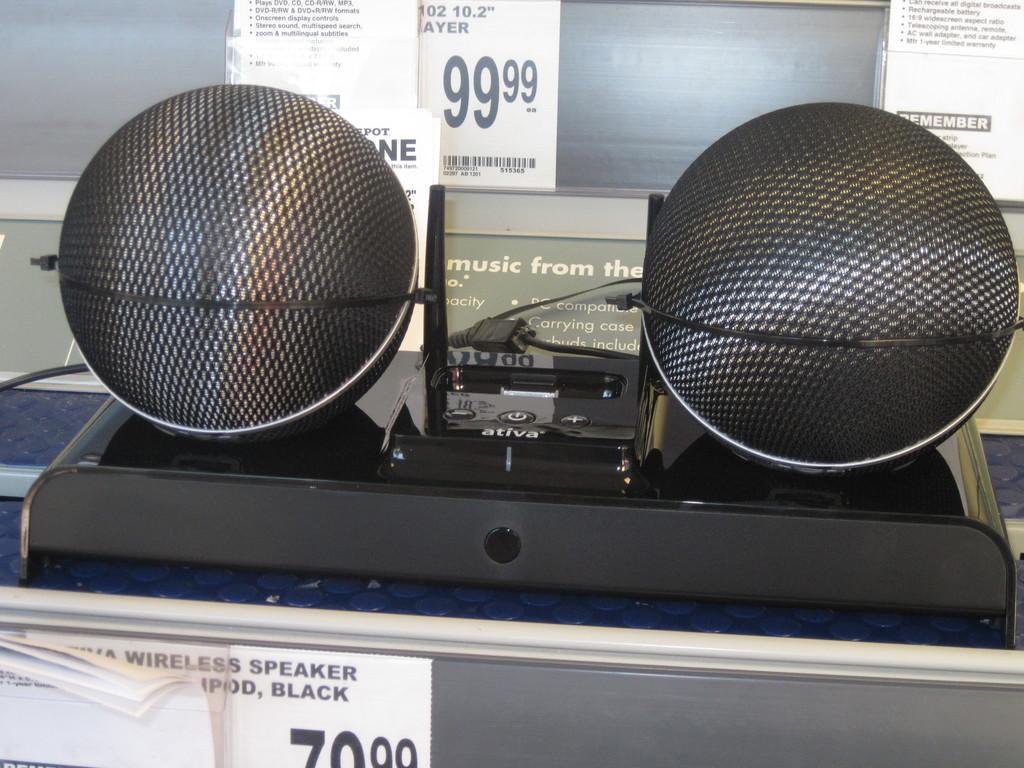Please provide a concise description of this image. Here we can see speakers on a platform and there are posters. In the background we can see glass. 